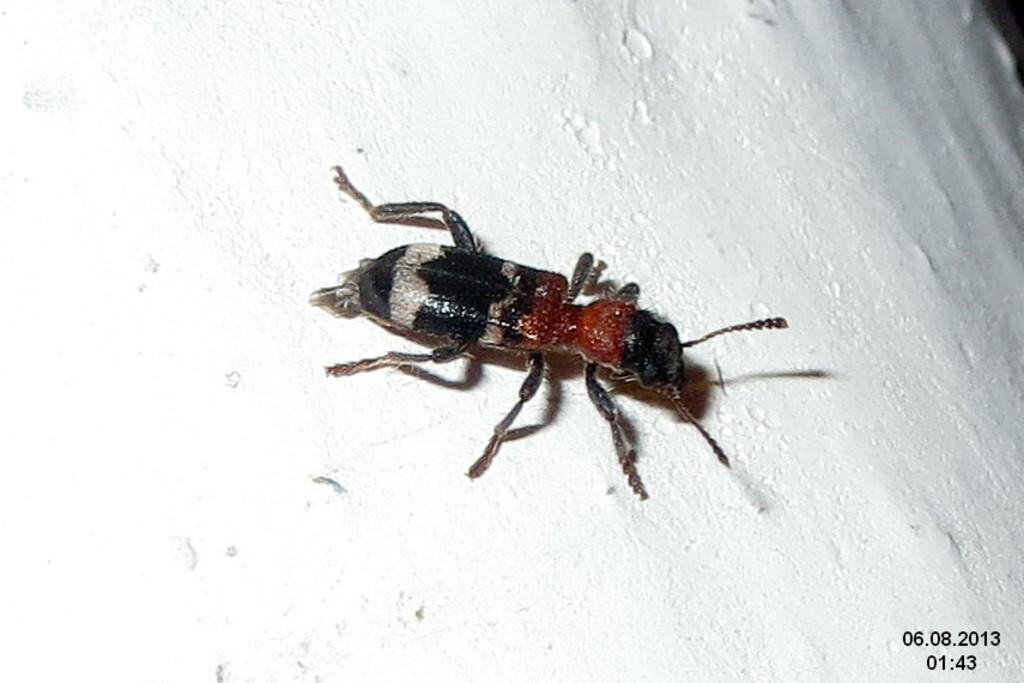What is present on the wall in the picture? There is an insect on the wall in the picture. Can you describe the insect's appearance? The insect has a white and black color pattern. What body parts does the insect have? The insect has legs and antenna. What type of button can be seen on the insect's back in the image? There is no button present on the insect's back in the image. Can you tell me how deep the lake is in the image? There is no lake present in the image; it features a wall with an insect on it. 